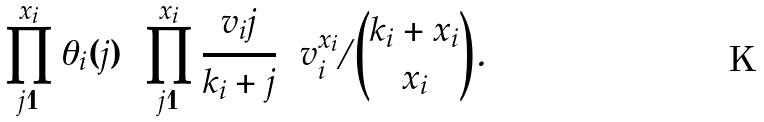Convert formula to latex. <formula><loc_0><loc_0><loc_500><loc_500>\prod _ { j = 1 } ^ { x _ { i } } \theta _ { i } ( j ) = \prod _ { j = 1 } ^ { x _ { i } } \frac { v _ { i } j } { k _ { i } + j } = v _ { i } ^ { x _ { i } } / \binom { k _ { i } + x _ { i } } { x _ { i } } .</formula> 